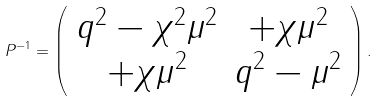Convert formula to latex. <formula><loc_0><loc_0><loc_500><loc_500>P ^ { - 1 } = \left ( \begin{array} { c c } q ^ { 2 } - \chi ^ { 2 } \mu ^ { 2 } & + \chi \mu ^ { 2 } \\ + \chi \mu ^ { 2 } & q ^ { 2 } - \mu ^ { 2 } \\ \end{array} \right ) .</formula> 